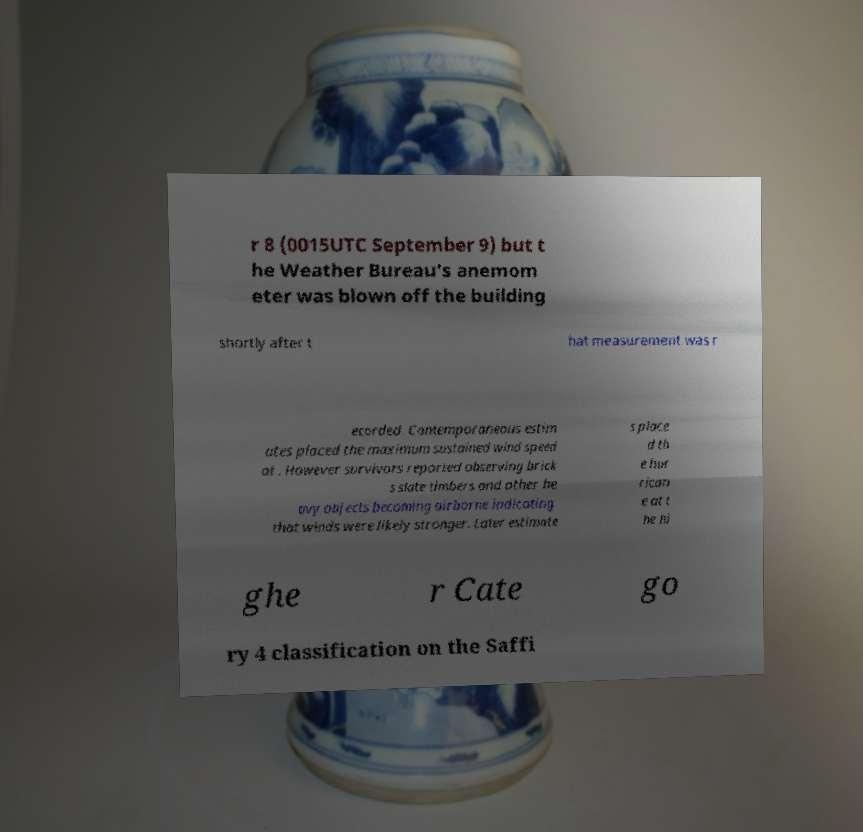For documentation purposes, I need the text within this image transcribed. Could you provide that? r 8 (0015UTC September 9) but t he Weather Bureau's anemom eter was blown off the building shortly after t hat measurement was r ecorded. Contemporaneous estim ates placed the maximum sustained wind speed at . However survivors reported observing brick s slate timbers and other he avy objects becoming airborne indicating that winds were likely stronger. Later estimate s place d th e hur rican e at t he hi ghe r Cate go ry 4 classification on the Saffi 